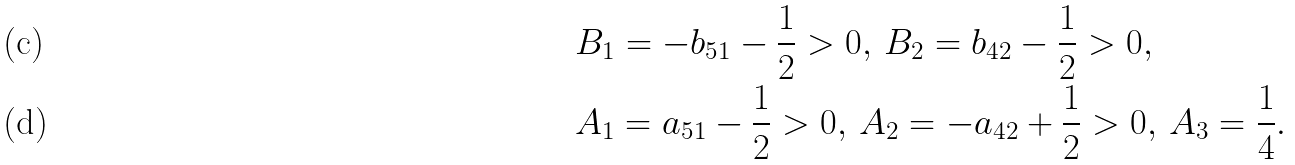Convert formula to latex. <formula><loc_0><loc_0><loc_500><loc_500>& B _ { 1 } = - b _ { 5 1 } - \frac { 1 } { 2 } > 0 , \, B _ { 2 } = b _ { 4 2 } - \frac { 1 } { 2 } > 0 , \\ & A _ { 1 } = a _ { 5 1 } - \frac { 1 } { 2 } > 0 , \, A _ { 2 } = - a _ { 4 2 } + \frac { 1 } { 2 } > 0 , \, A _ { 3 } = \frac { 1 } { 4 } .</formula> 